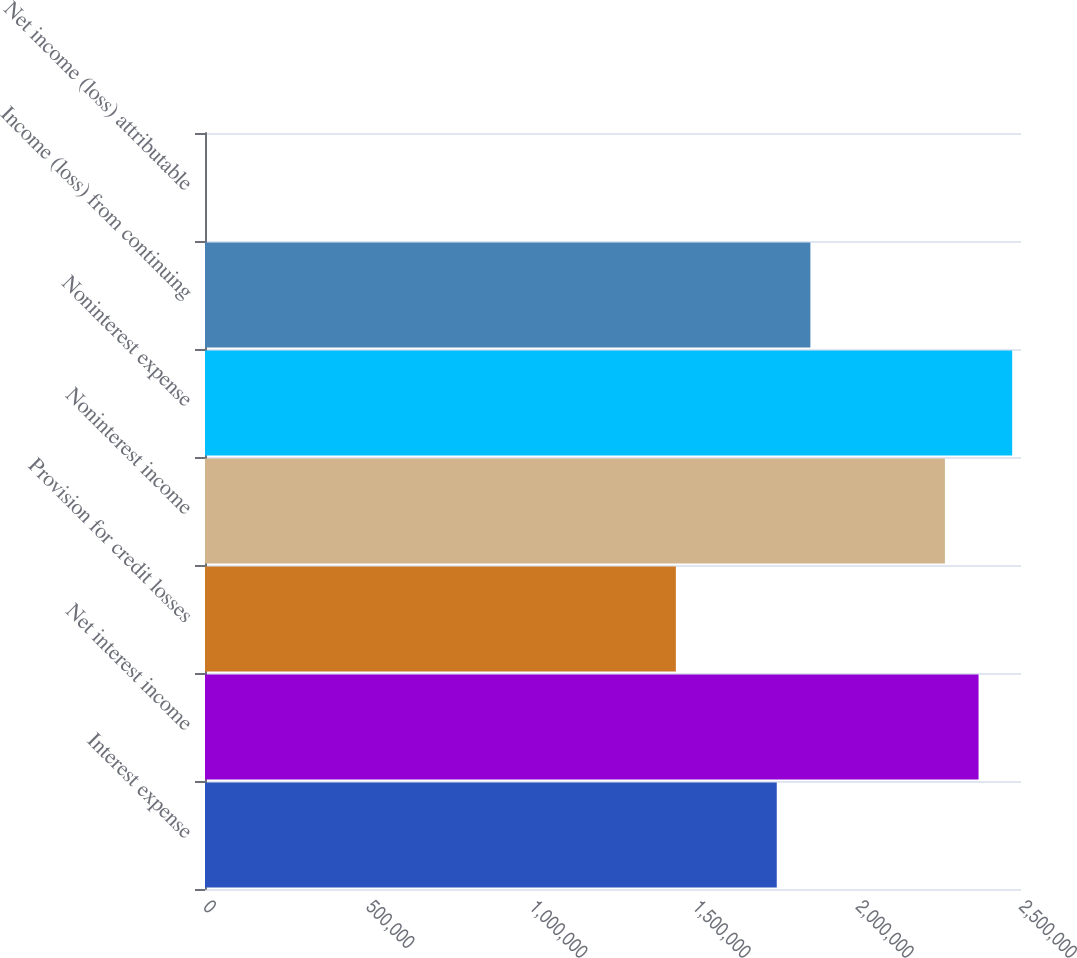<chart> <loc_0><loc_0><loc_500><loc_500><bar_chart><fcel>Interest expense<fcel>Net interest income<fcel>Provision for credit losses<fcel>Noninterest income<fcel>Noninterest expense<fcel>Income (loss) from continuing<fcel>Net income (loss) attributable<nl><fcel>1.75171e+06<fcel>2.36996e+06<fcel>1.44258e+06<fcel>2.26692e+06<fcel>2.473e+06<fcel>1.85475e+06<fcel>0.45<nl></chart> 